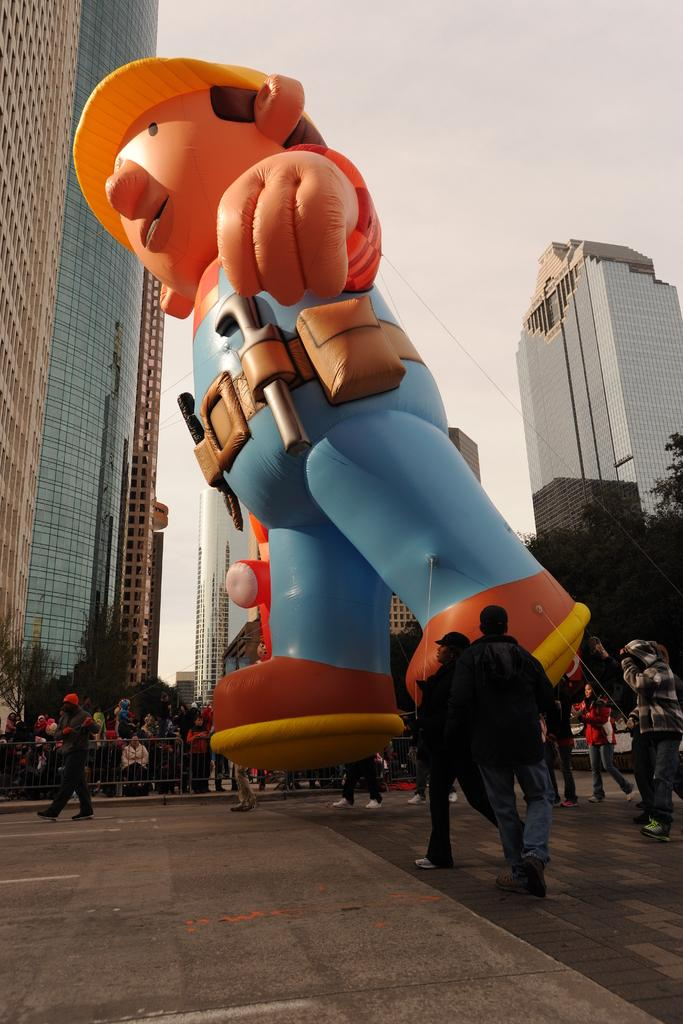What type of object is in the image? There is a toy balloon in the image. What are the people in the image doing? The people are standing and walking on the road. What can be seen in the background of the image? There are buildings and trees in the background of the image. What type of flag is being waved by the passenger in the image? There is no passenger or flag present in the image. 